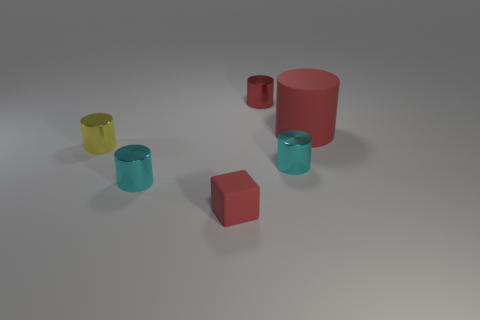Subtract all yellow cylinders. How many cylinders are left? 4 Subtract all large red rubber cylinders. How many cylinders are left? 4 Subtract all brown cylinders. Subtract all gray spheres. How many cylinders are left? 5 Add 4 red objects. How many objects exist? 10 Subtract all blocks. How many objects are left? 5 Subtract all green cylinders. Subtract all shiny objects. How many objects are left? 2 Add 6 red matte blocks. How many red matte blocks are left? 7 Add 1 small balls. How many small balls exist? 1 Subtract 0 yellow cubes. How many objects are left? 6 